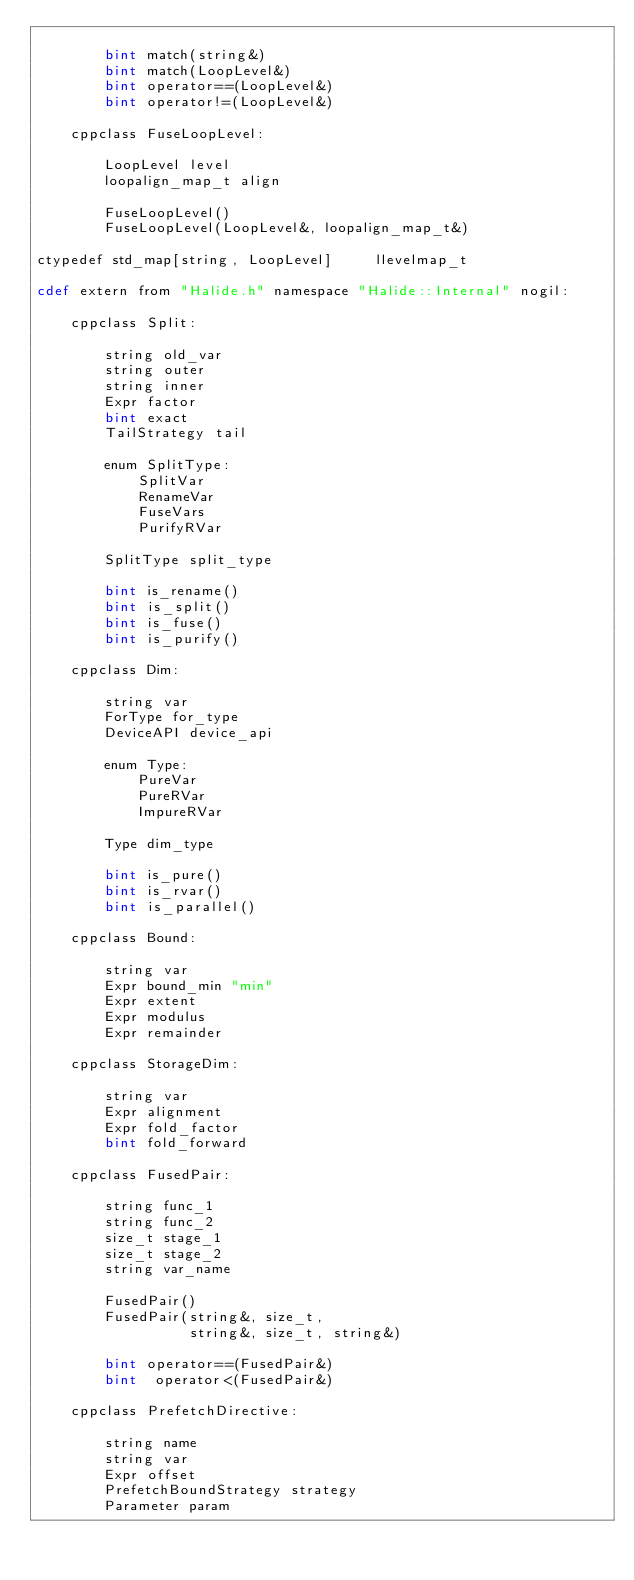<code> <loc_0><loc_0><loc_500><loc_500><_Cython_>        
        bint match(string&)
        bint match(LoopLevel&)
        bint operator==(LoopLevel&)
        bint operator!=(LoopLevel&)
    
    cppclass FuseLoopLevel:
        
        LoopLevel level
        loopalign_map_t align
        
        FuseLoopLevel()
        FuseLoopLevel(LoopLevel&, loopalign_map_t&)
        
ctypedef std_map[string, LoopLevel]     llevelmap_t

cdef extern from "Halide.h" namespace "Halide::Internal" nogil:
    
    cppclass Split:
        
        string old_var
        string outer
        string inner
        Expr factor
        bint exact
        TailStrategy tail
        
        enum SplitType:
            SplitVar
            RenameVar
            FuseVars
            PurifyRVar
        
        SplitType split_type
        
        bint is_rename()
        bint is_split()
        bint is_fuse()
        bint is_purify()
    
    cppclass Dim:
        
        string var
        ForType for_type
        DeviceAPI device_api
        
        enum Type:
            PureVar
            PureRVar
            ImpureRVar
        
        Type dim_type
        
        bint is_pure()
        bint is_rvar()
        bint is_parallel()
    
    cppclass Bound:
        
        string var
        Expr bound_min "min"
        Expr extent
        Expr modulus
        Expr remainder
    
    cppclass StorageDim:
        
        string var
        Expr alignment
        Expr fold_factor
        bint fold_forward
    
    cppclass FusedPair:
        
        string func_1
        string func_2
        size_t stage_1
        size_t stage_2
        string var_name
        
        FusedPair()
        FusedPair(string&, size_t,
                  string&, size_t, string&)
        
        bint operator==(FusedPair&)
        bint  operator<(FusedPair&)
    
    cppclass PrefetchDirective:
        
        string name
        string var
        Expr offset
        PrefetchBoundStrategy strategy
        Parameter param
    
    </code> 